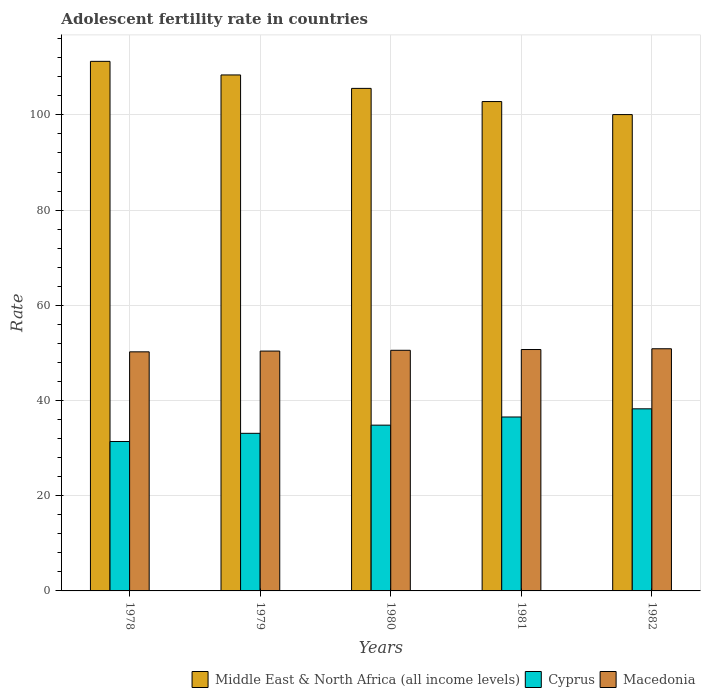How many different coloured bars are there?
Offer a very short reply. 3. How many groups of bars are there?
Your answer should be very brief. 5. Are the number of bars on each tick of the X-axis equal?
Offer a very short reply. Yes. How many bars are there on the 3rd tick from the left?
Offer a terse response. 3. How many bars are there on the 3rd tick from the right?
Your answer should be compact. 3. What is the label of the 1st group of bars from the left?
Your answer should be very brief. 1978. What is the adolescent fertility rate in Middle East & North Africa (all income levels) in 1980?
Your answer should be compact. 105.57. Across all years, what is the maximum adolescent fertility rate in Cyprus?
Give a very brief answer. 38.25. Across all years, what is the minimum adolescent fertility rate in Middle East & North Africa (all income levels)?
Give a very brief answer. 100.06. In which year was the adolescent fertility rate in Macedonia maximum?
Ensure brevity in your answer.  1982. In which year was the adolescent fertility rate in Macedonia minimum?
Your response must be concise. 1978. What is the total adolescent fertility rate in Cyprus in the graph?
Ensure brevity in your answer.  174.11. What is the difference between the adolescent fertility rate in Cyprus in 1981 and that in 1982?
Your response must be concise. -1.72. What is the difference between the adolescent fertility rate in Cyprus in 1981 and the adolescent fertility rate in Macedonia in 1979?
Offer a terse response. -13.85. What is the average adolescent fertility rate in Cyprus per year?
Offer a terse response. 34.82. In the year 1982, what is the difference between the adolescent fertility rate in Middle East & North Africa (all income levels) and adolescent fertility rate in Macedonia?
Offer a terse response. 49.19. What is the ratio of the adolescent fertility rate in Cyprus in 1980 to that in 1982?
Ensure brevity in your answer.  0.91. Is the difference between the adolescent fertility rate in Middle East & North Africa (all income levels) in 1978 and 1982 greater than the difference between the adolescent fertility rate in Macedonia in 1978 and 1982?
Provide a short and direct response. Yes. What is the difference between the highest and the second highest adolescent fertility rate in Middle East & North Africa (all income levels)?
Offer a terse response. 2.85. What is the difference between the highest and the lowest adolescent fertility rate in Macedonia?
Provide a succinct answer. 0.65. In how many years, is the adolescent fertility rate in Middle East & North Africa (all income levels) greater than the average adolescent fertility rate in Middle East & North Africa (all income levels) taken over all years?
Provide a short and direct response. 2. What does the 1st bar from the left in 1979 represents?
Provide a succinct answer. Middle East & North Africa (all income levels). What does the 1st bar from the right in 1979 represents?
Provide a succinct answer. Macedonia. Are all the bars in the graph horizontal?
Offer a very short reply. No. Does the graph contain any zero values?
Make the answer very short. No. Does the graph contain grids?
Provide a succinct answer. Yes. Where does the legend appear in the graph?
Give a very brief answer. Bottom right. How are the legend labels stacked?
Provide a short and direct response. Horizontal. What is the title of the graph?
Your response must be concise. Adolescent fertility rate in countries. What is the label or title of the Y-axis?
Offer a very short reply. Rate. What is the Rate of Middle East & North Africa (all income levels) in 1978?
Make the answer very short. 111.24. What is the Rate of Cyprus in 1978?
Offer a very short reply. 31.39. What is the Rate in Macedonia in 1978?
Your answer should be compact. 50.22. What is the Rate in Middle East & North Africa (all income levels) in 1979?
Your answer should be very brief. 108.39. What is the Rate in Cyprus in 1979?
Your answer should be very brief. 33.11. What is the Rate of Macedonia in 1979?
Your response must be concise. 50.39. What is the Rate of Middle East & North Africa (all income levels) in 1980?
Your answer should be very brief. 105.57. What is the Rate of Cyprus in 1980?
Your answer should be compact. 34.82. What is the Rate of Macedonia in 1980?
Provide a short and direct response. 50.55. What is the Rate in Middle East & North Africa (all income levels) in 1981?
Your response must be concise. 102.8. What is the Rate of Cyprus in 1981?
Your answer should be very brief. 36.54. What is the Rate in Macedonia in 1981?
Offer a terse response. 50.71. What is the Rate of Middle East & North Africa (all income levels) in 1982?
Provide a short and direct response. 100.06. What is the Rate in Cyprus in 1982?
Give a very brief answer. 38.25. What is the Rate of Macedonia in 1982?
Give a very brief answer. 50.87. Across all years, what is the maximum Rate in Middle East & North Africa (all income levels)?
Provide a succinct answer. 111.24. Across all years, what is the maximum Rate in Cyprus?
Give a very brief answer. 38.25. Across all years, what is the maximum Rate in Macedonia?
Provide a succinct answer. 50.87. Across all years, what is the minimum Rate in Middle East & North Africa (all income levels)?
Keep it short and to the point. 100.06. Across all years, what is the minimum Rate of Cyprus?
Your answer should be very brief. 31.39. Across all years, what is the minimum Rate of Macedonia?
Provide a succinct answer. 50.22. What is the total Rate in Middle East & North Africa (all income levels) in the graph?
Offer a terse response. 528.06. What is the total Rate in Cyprus in the graph?
Your answer should be very brief. 174.11. What is the total Rate in Macedonia in the graph?
Give a very brief answer. 252.74. What is the difference between the Rate in Middle East & North Africa (all income levels) in 1978 and that in 1979?
Provide a succinct answer. 2.85. What is the difference between the Rate in Cyprus in 1978 and that in 1979?
Make the answer very short. -1.72. What is the difference between the Rate of Macedonia in 1978 and that in 1979?
Your response must be concise. -0.16. What is the difference between the Rate of Middle East & North Africa (all income levels) in 1978 and that in 1980?
Keep it short and to the point. 5.68. What is the difference between the Rate of Cyprus in 1978 and that in 1980?
Keep it short and to the point. -3.43. What is the difference between the Rate in Macedonia in 1978 and that in 1980?
Your response must be concise. -0.32. What is the difference between the Rate in Middle East & North Africa (all income levels) in 1978 and that in 1981?
Give a very brief answer. 8.44. What is the difference between the Rate in Cyprus in 1978 and that in 1981?
Your response must be concise. -5.15. What is the difference between the Rate of Macedonia in 1978 and that in 1981?
Provide a succinct answer. -0.49. What is the difference between the Rate in Middle East & North Africa (all income levels) in 1978 and that in 1982?
Your answer should be compact. 11.18. What is the difference between the Rate in Cyprus in 1978 and that in 1982?
Your response must be concise. -6.86. What is the difference between the Rate of Macedonia in 1978 and that in 1982?
Make the answer very short. -0.65. What is the difference between the Rate in Middle East & North Africa (all income levels) in 1979 and that in 1980?
Your answer should be compact. 2.82. What is the difference between the Rate in Cyprus in 1979 and that in 1980?
Offer a terse response. -1.72. What is the difference between the Rate of Macedonia in 1979 and that in 1980?
Ensure brevity in your answer.  -0.16. What is the difference between the Rate of Middle East & North Africa (all income levels) in 1979 and that in 1981?
Offer a very short reply. 5.59. What is the difference between the Rate in Cyprus in 1979 and that in 1981?
Provide a short and direct response. -3.43. What is the difference between the Rate in Macedonia in 1979 and that in 1981?
Your response must be concise. -0.32. What is the difference between the Rate of Middle East & North Africa (all income levels) in 1979 and that in 1982?
Give a very brief answer. 8.33. What is the difference between the Rate of Cyprus in 1979 and that in 1982?
Ensure brevity in your answer.  -5.15. What is the difference between the Rate in Macedonia in 1979 and that in 1982?
Your response must be concise. -0.49. What is the difference between the Rate in Middle East & North Africa (all income levels) in 1980 and that in 1981?
Your response must be concise. 2.77. What is the difference between the Rate of Cyprus in 1980 and that in 1981?
Your response must be concise. -1.72. What is the difference between the Rate of Macedonia in 1980 and that in 1981?
Provide a short and direct response. -0.16. What is the difference between the Rate of Middle East & North Africa (all income levels) in 1980 and that in 1982?
Your answer should be very brief. 5.5. What is the difference between the Rate in Cyprus in 1980 and that in 1982?
Make the answer very short. -3.43. What is the difference between the Rate in Macedonia in 1980 and that in 1982?
Keep it short and to the point. -0.32. What is the difference between the Rate of Middle East & North Africa (all income levels) in 1981 and that in 1982?
Your response must be concise. 2.74. What is the difference between the Rate in Cyprus in 1981 and that in 1982?
Your response must be concise. -1.72. What is the difference between the Rate of Macedonia in 1981 and that in 1982?
Your answer should be compact. -0.16. What is the difference between the Rate in Middle East & North Africa (all income levels) in 1978 and the Rate in Cyprus in 1979?
Provide a succinct answer. 78.14. What is the difference between the Rate of Middle East & North Africa (all income levels) in 1978 and the Rate of Macedonia in 1979?
Offer a terse response. 60.86. What is the difference between the Rate of Cyprus in 1978 and the Rate of Macedonia in 1979?
Ensure brevity in your answer.  -18.99. What is the difference between the Rate of Middle East & North Africa (all income levels) in 1978 and the Rate of Cyprus in 1980?
Offer a terse response. 76.42. What is the difference between the Rate in Middle East & North Africa (all income levels) in 1978 and the Rate in Macedonia in 1980?
Your answer should be compact. 60.7. What is the difference between the Rate in Cyprus in 1978 and the Rate in Macedonia in 1980?
Offer a very short reply. -19.16. What is the difference between the Rate of Middle East & North Africa (all income levels) in 1978 and the Rate of Cyprus in 1981?
Offer a very short reply. 74.71. What is the difference between the Rate of Middle East & North Africa (all income levels) in 1978 and the Rate of Macedonia in 1981?
Make the answer very short. 60.53. What is the difference between the Rate in Cyprus in 1978 and the Rate in Macedonia in 1981?
Your answer should be compact. -19.32. What is the difference between the Rate of Middle East & North Africa (all income levels) in 1978 and the Rate of Cyprus in 1982?
Your answer should be very brief. 72.99. What is the difference between the Rate of Middle East & North Africa (all income levels) in 1978 and the Rate of Macedonia in 1982?
Provide a succinct answer. 60.37. What is the difference between the Rate of Cyprus in 1978 and the Rate of Macedonia in 1982?
Offer a terse response. -19.48. What is the difference between the Rate in Middle East & North Africa (all income levels) in 1979 and the Rate in Cyprus in 1980?
Offer a terse response. 73.57. What is the difference between the Rate in Middle East & North Africa (all income levels) in 1979 and the Rate in Macedonia in 1980?
Your answer should be very brief. 57.84. What is the difference between the Rate in Cyprus in 1979 and the Rate in Macedonia in 1980?
Provide a short and direct response. -17.44. What is the difference between the Rate of Middle East & North Africa (all income levels) in 1979 and the Rate of Cyprus in 1981?
Offer a terse response. 71.85. What is the difference between the Rate in Middle East & North Africa (all income levels) in 1979 and the Rate in Macedonia in 1981?
Your answer should be very brief. 57.68. What is the difference between the Rate of Cyprus in 1979 and the Rate of Macedonia in 1981?
Provide a short and direct response. -17.6. What is the difference between the Rate of Middle East & North Africa (all income levels) in 1979 and the Rate of Cyprus in 1982?
Provide a succinct answer. 70.14. What is the difference between the Rate of Middle East & North Africa (all income levels) in 1979 and the Rate of Macedonia in 1982?
Your answer should be compact. 57.52. What is the difference between the Rate in Cyprus in 1979 and the Rate in Macedonia in 1982?
Your answer should be very brief. -17.77. What is the difference between the Rate in Middle East & North Africa (all income levels) in 1980 and the Rate in Cyprus in 1981?
Your answer should be compact. 69.03. What is the difference between the Rate of Middle East & North Africa (all income levels) in 1980 and the Rate of Macedonia in 1981?
Offer a very short reply. 54.86. What is the difference between the Rate in Cyprus in 1980 and the Rate in Macedonia in 1981?
Give a very brief answer. -15.89. What is the difference between the Rate in Middle East & North Africa (all income levels) in 1980 and the Rate in Cyprus in 1982?
Offer a very short reply. 67.31. What is the difference between the Rate in Middle East & North Africa (all income levels) in 1980 and the Rate in Macedonia in 1982?
Provide a short and direct response. 54.69. What is the difference between the Rate in Cyprus in 1980 and the Rate in Macedonia in 1982?
Provide a succinct answer. -16.05. What is the difference between the Rate in Middle East & North Africa (all income levels) in 1981 and the Rate in Cyprus in 1982?
Keep it short and to the point. 64.55. What is the difference between the Rate of Middle East & North Africa (all income levels) in 1981 and the Rate of Macedonia in 1982?
Keep it short and to the point. 51.93. What is the difference between the Rate of Cyprus in 1981 and the Rate of Macedonia in 1982?
Keep it short and to the point. -14.33. What is the average Rate in Middle East & North Africa (all income levels) per year?
Offer a very short reply. 105.61. What is the average Rate in Cyprus per year?
Make the answer very short. 34.82. What is the average Rate in Macedonia per year?
Provide a succinct answer. 50.55. In the year 1978, what is the difference between the Rate of Middle East & North Africa (all income levels) and Rate of Cyprus?
Your response must be concise. 79.85. In the year 1978, what is the difference between the Rate in Middle East & North Africa (all income levels) and Rate in Macedonia?
Your response must be concise. 61.02. In the year 1978, what is the difference between the Rate of Cyprus and Rate of Macedonia?
Offer a terse response. -18.83. In the year 1979, what is the difference between the Rate of Middle East & North Africa (all income levels) and Rate of Cyprus?
Your answer should be compact. 75.28. In the year 1979, what is the difference between the Rate in Middle East & North Africa (all income levels) and Rate in Macedonia?
Your response must be concise. 58. In the year 1979, what is the difference between the Rate in Cyprus and Rate in Macedonia?
Give a very brief answer. -17.28. In the year 1980, what is the difference between the Rate in Middle East & North Africa (all income levels) and Rate in Cyprus?
Make the answer very short. 70.74. In the year 1980, what is the difference between the Rate in Middle East & North Africa (all income levels) and Rate in Macedonia?
Make the answer very short. 55.02. In the year 1980, what is the difference between the Rate of Cyprus and Rate of Macedonia?
Provide a short and direct response. -15.73. In the year 1981, what is the difference between the Rate of Middle East & North Africa (all income levels) and Rate of Cyprus?
Offer a terse response. 66.26. In the year 1981, what is the difference between the Rate in Middle East & North Africa (all income levels) and Rate in Macedonia?
Make the answer very short. 52.09. In the year 1981, what is the difference between the Rate of Cyprus and Rate of Macedonia?
Offer a terse response. -14.17. In the year 1982, what is the difference between the Rate in Middle East & North Africa (all income levels) and Rate in Cyprus?
Offer a very short reply. 61.81. In the year 1982, what is the difference between the Rate of Middle East & North Africa (all income levels) and Rate of Macedonia?
Provide a succinct answer. 49.19. In the year 1982, what is the difference between the Rate of Cyprus and Rate of Macedonia?
Provide a short and direct response. -12.62. What is the ratio of the Rate of Middle East & North Africa (all income levels) in 1978 to that in 1979?
Give a very brief answer. 1.03. What is the ratio of the Rate in Cyprus in 1978 to that in 1979?
Your answer should be compact. 0.95. What is the ratio of the Rate in Middle East & North Africa (all income levels) in 1978 to that in 1980?
Offer a terse response. 1.05. What is the ratio of the Rate in Cyprus in 1978 to that in 1980?
Your answer should be very brief. 0.9. What is the ratio of the Rate of Middle East & North Africa (all income levels) in 1978 to that in 1981?
Provide a succinct answer. 1.08. What is the ratio of the Rate in Cyprus in 1978 to that in 1981?
Your answer should be compact. 0.86. What is the ratio of the Rate of Macedonia in 1978 to that in 1981?
Offer a terse response. 0.99. What is the ratio of the Rate of Middle East & North Africa (all income levels) in 1978 to that in 1982?
Give a very brief answer. 1.11. What is the ratio of the Rate of Cyprus in 1978 to that in 1982?
Your answer should be very brief. 0.82. What is the ratio of the Rate of Macedonia in 1978 to that in 1982?
Your answer should be very brief. 0.99. What is the ratio of the Rate in Middle East & North Africa (all income levels) in 1979 to that in 1980?
Your answer should be very brief. 1.03. What is the ratio of the Rate of Cyprus in 1979 to that in 1980?
Provide a succinct answer. 0.95. What is the ratio of the Rate of Macedonia in 1979 to that in 1980?
Give a very brief answer. 1. What is the ratio of the Rate of Middle East & North Africa (all income levels) in 1979 to that in 1981?
Your response must be concise. 1.05. What is the ratio of the Rate of Cyprus in 1979 to that in 1981?
Your response must be concise. 0.91. What is the ratio of the Rate of Middle East & North Africa (all income levels) in 1979 to that in 1982?
Offer a terse response. 1.08. What is the ratio of the Rate of Cyprus in 1979 to that in 1982?
Give a very brief answer. 0.87. What is the ratio of the Rate in Middle East & North Africa (all income levels) in 1980 to that in 1981?
Your answer should be compact. 1.03. What is the ratio of the Rate in Cyprus in 1980 to that in 1981?
Provide a short and direct response. 0.95. What is the ratio of the Rate of Macedonia in 1980 to that in 1981?
Keep it short and to the point. 1. What is the ratio of the Rate in Middle East & North Africa (all income levels) in 1980 to that in 1982?
Your answer should be very brief. 1.05. What is the ratio of the Rate of Cyprus in 1980 to that in 1982?
Provide a short and direct response. 0.91. What is the ratio of the Rate of Middle East & North Africa (all income levels) in 1981 to that in 1982?
Ensure brevity in your answer.  1.03. What is the ratio of the Rate of Cyprus in 1981 to that in 1982?
Offer a terse response. 0.96. What is the ratio of the Rate of Macedonia in 1981 to that in 1982?
Your response must be concise. 1. What is the difference between the highest and the second highest Rate of Middle East & North Africa (all income levels)?
Make the answer very short. 2.85. What is the difference between the highest and the second highest Rate of Cyprus?
Give a very brief answer. 1.72. What is the difference between the highest and the second highest Rate of Macedonia?
Offer a terse response. 0.16. What is the difference between the highest and the lowest Rate of Middle East & North Africa (all income levels)?
Offer a very short reply. 11.18. What is the difference between the highest and the lowest Rate in Cyprus?
Your answer should be compact. 6.86. What is the difference between the highest and the lowest Rate in Macedonia?
Provide a short and direct response. 0.65. 